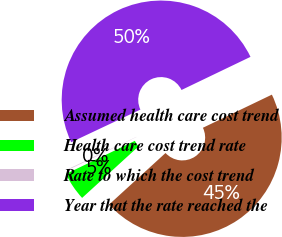Convert chart to OTSL. <chart><loc_0><loc_0><loc_500><loc_500><pie_chart><fcel>Assumed health care cost trend<fcel>Health care cost trend rate<fcel>Rate to which the cost trend<fcel>Year that the rate reached the<nl><fcel>45.35%<fcel>4.65%<fcel>0.11%<fcel>49.89%<nl></chart> 